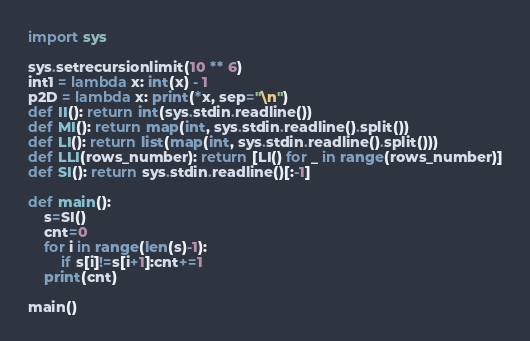<code> <loc_0><loc_0><loc_500><loc_500><_Python_>import sys

sys.setrecursionlimit(10 ** 6)
int1 = lambda x: int(x) - 1
p2D = lambda x: print(*x, sep="\n")
def II(): return int(sys.stdin.readline())
def MI(): return map(int, sys.stdin.readline().split())
def LI(): return list(map(int, sys.stdin.readline().split()))
def LLI(rows_number): return [LI() for _ in range(rows_number)]
def SI(): return sys.stdin.readline()[:-1]

def main():
    s=SI()
    cnt=0
    for i in range(len(s)-1):
        if s[i]!=s[i+1]:cnt+=1
    print(cnt)

main()</code> 